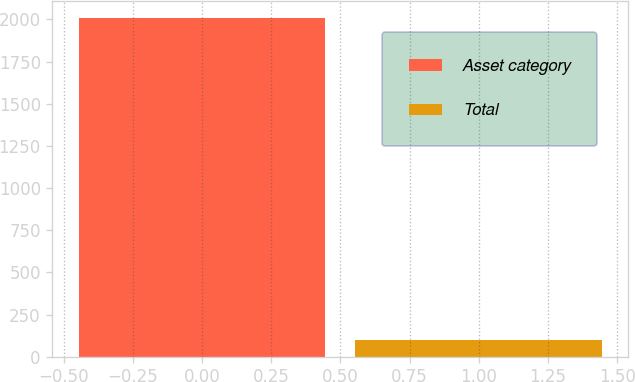Convert chart. <chart><loc_0><loc_0><loc_500><loc_500><bar_chart><fcel>Asset category<fcel>Total<nl><fcel>2011<fcel>100<nl></chart> 